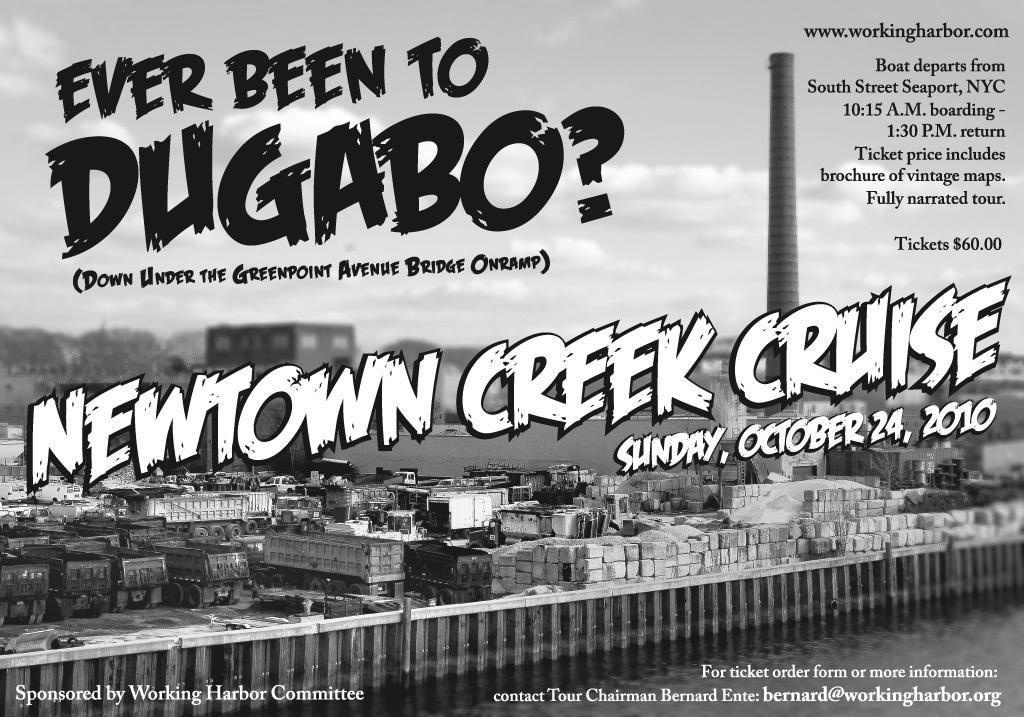When is the newton creek cruise?
Your answer should be compact. Sunday, october 24, 2010. When is this cruise?
Your response must be concise. October 24, 2010. 